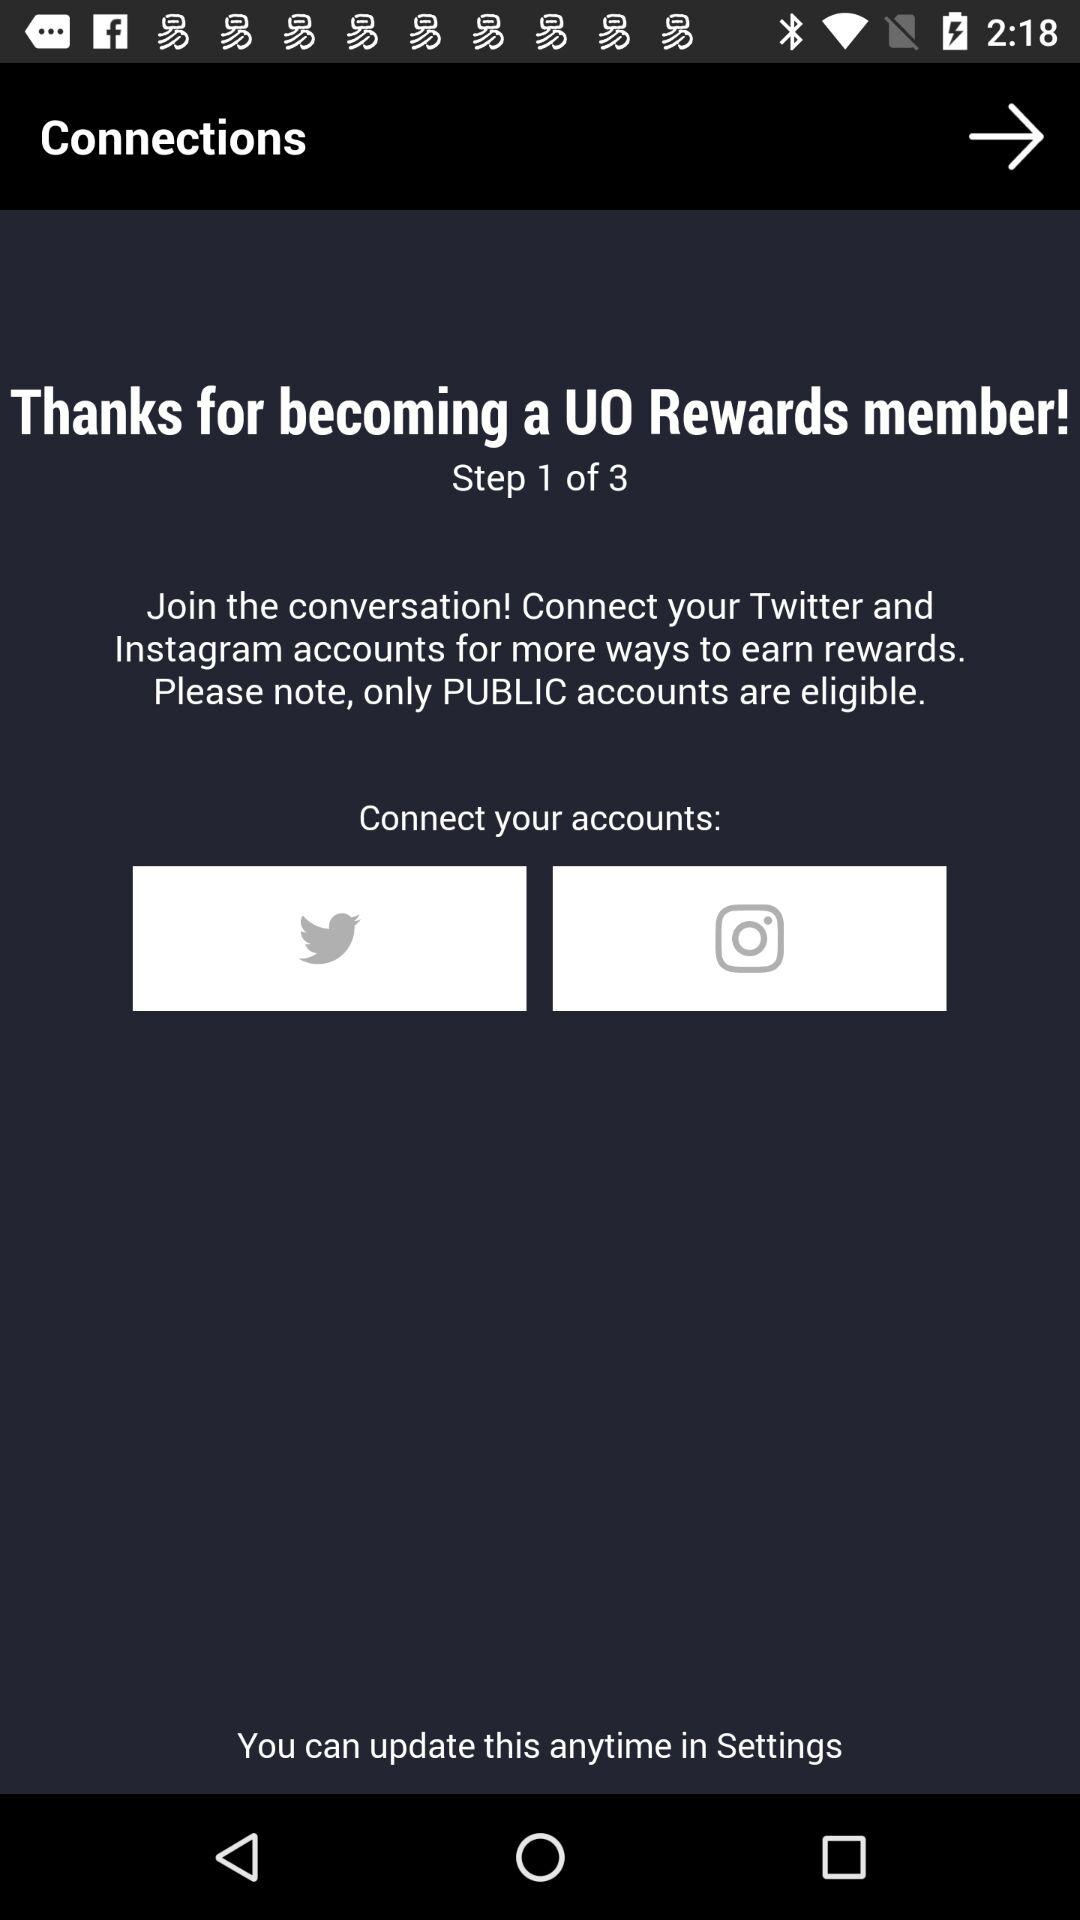How many accounts can I connect?
Answer the question using a single word or phrase. 2 